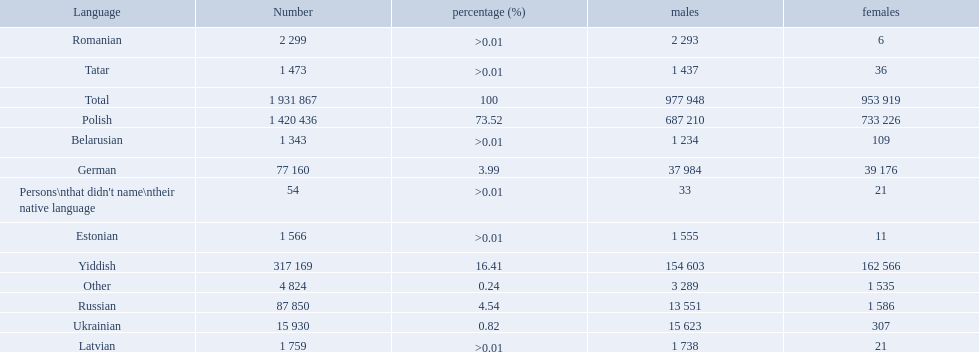What is the percentage of polish speakers? 73.52. What is the next highest percentage of speakers? 16.41. What language is this percentage? Yiddish. What are all the languages? Polish, Yiddish, Russian, German, Ukrainian, Romanian, Latvian, Estonian, Tatar, Belarusian, Other. Which only have percentages >0.01? Romanian, Latvian, Estonian, Tatar, Belarusian. Of these, which has the greatest number of speakers? Romanian. 